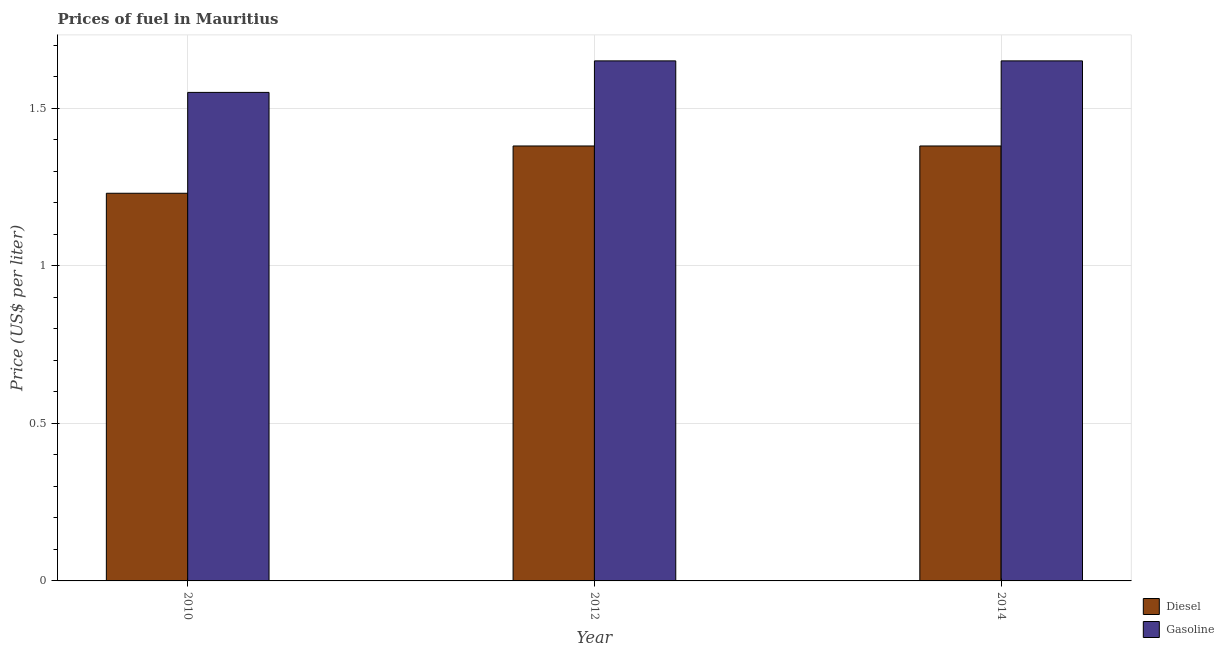How many different coloured bars are there?
Your answer should be compact. 2. How many groups of bars are there?
Your response must be concise. 3. How many bars are there on the 3rd tick from the left?
Your answer should be very brief. 2. How many bars are there on the 1st tick from the right?
Provide a succinct answer. 2. What is the label of the 2nd group of bars from the left?
Your answer should be compact. 2012. In how many cases, is the number of bars for a given year not equal to the number of legend labels?
Ensure brevity in your answer.  0. What is the diesel price in 2014?
Provide a succinct answer. 1.38. Across all years, what is the maximum diesel price?
Ensure brevity in your answer.  1.38. Across all years, what is the minimum gasoline price?
Your response must be concise. 1.55. In which year was the gasoline price maximum?
Offer a very short reply. 2012. What is the total gasoline price in the graph?
Your answer should be very brief. 4.85. What is the difference between the gasoline price in 2014 and the diesel price in 2010?
Give a very brief answer. 0.1. What is the average gasoline price per year?
Ensure brevity in your answer.  1.62. In the year 2014, what is the difference between the gasoline price and diesel price?
Ensure brevity in your answer.  0. What is the ratio of the gasoline price in 2010 to that in 2012?
Provide a succinct answer. 0.94. Is the gasoline price in 2012 less than that in 2014?
Give a very brief answer. No. What is the difference between the highest and the lowest gasoline price?
Keep it short and to the point. 0.1. In how many years, is the gasoline price greater than the average gasoline price taken over all years?
Offer a terse response. 2. Is the sum of the diesel price in 2010 and 2014 greater than the maximum gasoline price across all years?
Ensure brevity in your answer.  Yes. What does the 1st bar from the left in 2010 represents?
Keep it short and to the point. Diesel. What does the 1st bar from the right in 2014 represents?
Keep it short and to the point. Gasoline. How many bars are there?
Offer a very short reply. 6. Are all the bars in the graph horizontal?
Your answer should be very brief. No. Where does the legend appear in the graph?
Ensure brevity in your answer.  Bottom right. How many legend labels are there?
Ensure brevity in your answer.  2. How are the legend labels stacked?
Offer a terse response. Vertical. What is the title of the graph?
Keep it short and to the point. Prices of fuel in Mauritius. Does "Primary education" appear as one of the legend labels in the graph?
Your answer should be compact. No. What is the label or title of the Y-axis?
Offer a terse response. Price (US$ per liter). What is the Price (US$ per liter) of Diesel in 2010?
Offer a very short reply. 1.23. What is the Price (US$ per liter) of Gasoline in 2010?
Keep it short and to the point. 1.55. What is the Price (US$ per liter) in Diesel in 2012?
Offer a very short reply. 1.38. What is the Price (US$ per liter) in Gasoline in 2012?
Your response must be concise. 1.65. What is the Price (US$ per liter) in Diesel in 2014?
Keep it short and to the point. 1.38. What is the Price (US$ per liter) of Gasoline in 2014?
Provide a short and direct response. 1.65. Across all years, what is the maximum Price (US$ per liter) of Diesel?
Provide a succinct answer. 1.38. Across all years, what is the maximum Price (US$ per liter) of Gasoline?
Offer a very short reply. 1.65. Across all years, what is the minimum Price (US$ per liter) in Diesel?
Your answer should be compact. 1.23. Across all years, what is the minimum Price (US$ per liter) of Gasoline?
Offer a terse response. 1.55. What is the total Price (US$ per liter) of Diesel in the graph?
Your response must be concise. 3.99. What is the total Price (US$ per liter) of Gasoline in the graph?
Provide a succinct answer. 4.85. What is the difference between the Price (US$ per liter) in Diesel in 2010 and that in 2012?
Provide a succinct answer. -0.15. What is the difference between the Price (US$ per liter) of Gasoline in 2010 and that in 2012?
Ensure brevity in your answer.  -0.1. What is the difference between the Price (US$ per liter) of Diesel in 2010 and that in 2014?
Your answer should be compact. -0.15. What is the difference between the Price (US$ per liter) of Diesel in 2010 and the Price (US$ per liter) of Gasoline in 2012?
Your answer should be very brief. -0.42. What is the difference between the Price (US$ per liter) in Diesel in 2010 and the Price (US$ per liter) in Gasoline in 2014?
Give a very brief answer. -0.42. What is the difference between the Price (US$ per liter) of Diesel in 2012 and the Price (US$ per liter) of Gasoline in 2014?
Your answer should be very brief. -0.27. What is the average Price (US$ per liter) of Diesel per year?
Give a very brief answer. 1.33. What is the average Price (US$ per liter) of Gasoline per year?
Make the answer very short. 1.62. In the year 2010, what is the difference between the Price (US$ per liter) in Diesel and Price (US$ per liter) in Gasoline?
Provide a succinct answer. -0.32. In the year 2012, what is the difference between the Price (US$ per liter) in Diesel and Price (US$ per liter) in Gasoline?
Offer a terse response. -0.27. In the year 2014, what is the difference between the Price (US$ per liter) of Diesel and Price (US$ per liter) of Gasoline?
Keep it short and to the point. -0.27. What is the ratio of the Price (US$ per liter) of Diesel in 2010 to that in 2012?
Provide a succinct answer. 0.89. What is the ratio of the Price (US$ per liter) of Gasoline in 2010 to that in 2012?
Provide a short and direct response. 0.94. What is the ratio of the Price (US$ per liter) in Diesel in 2010 to that in 2014?
Your response must be concise. 0.89. What is the ratio of the Price (US$ per liter) in Gasoline in 2010 to that in 2014?
Give a very brief answer. 0.94. What is the ratio of the Price (US$ per liter) of Gasoline in 2012 to that in 2014?
Your answer should be very brief. 1. What is the difference between the highest and the second highest Price (US$ per liter) of Diesel?
Offer a terse response. 0. What is the difference between the highest and the second highest Price (US$ per liter) in Gasoline?
Offer a very short reply. 0. What is the difference between the highest and the lowest Price (US$ per liter) of Diesel?
Provide a succinct answer. 0.15. What is the difference between the highest and the lowest Price (US$ per liter) of Gasoline?
Keep it short and to the point. 0.1. 